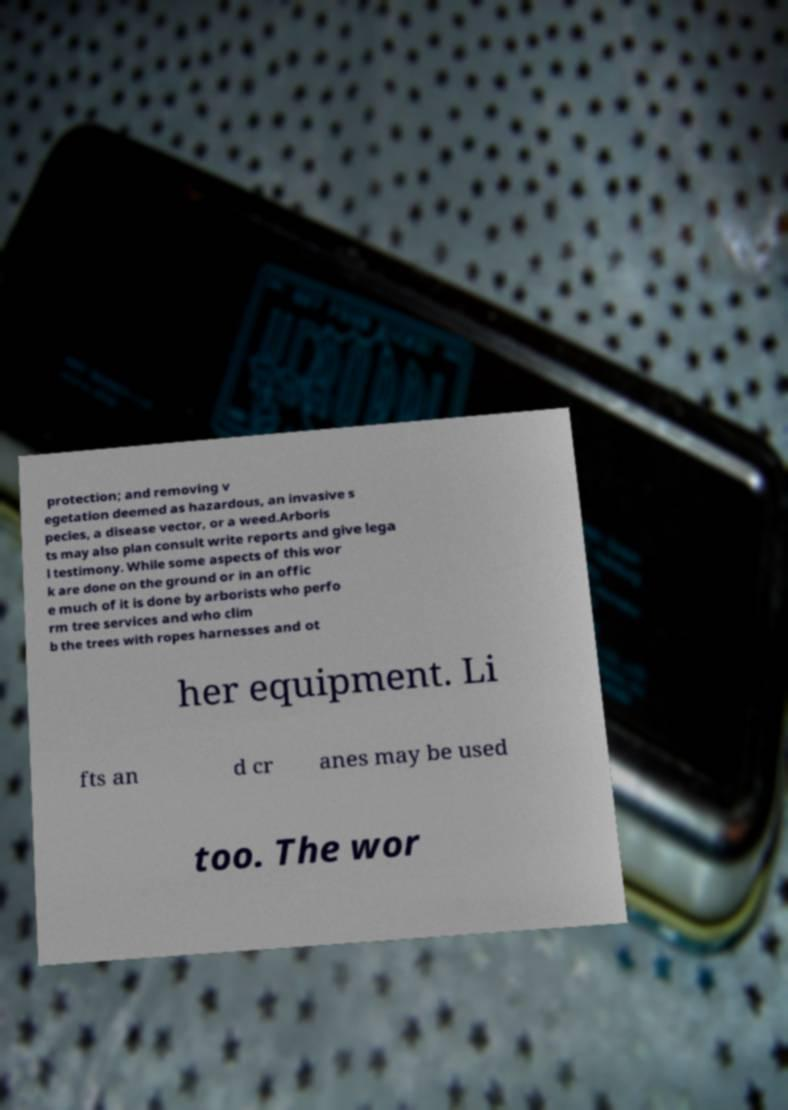I need the written content from this picture converted into text. Can you do that? protection; and removing v egetation deemed as hazardous, an invasive s pecies, a disease vector, or a weed.Arboris ts may also plan consult write reports and give lega l testimony. While some aspects of this wor k are done on the ground or in an offic e much of it is done by arborists who perfo rm tree services and who clim b the trees with ropes harnesses and ot her equipment. Li fts an d cr anes may be used too. The wor 